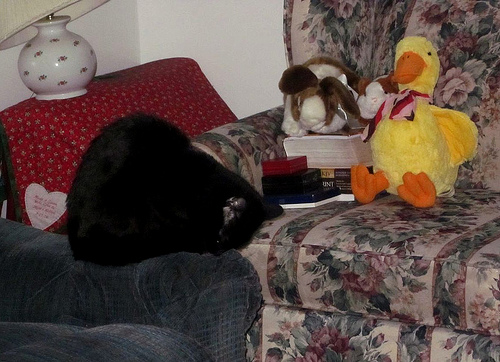<image>
Is there a cat on the couch? No. The cat is not positioned on the couch. They may be near each other, but the cat is not supported by or resting on top of the couch. 